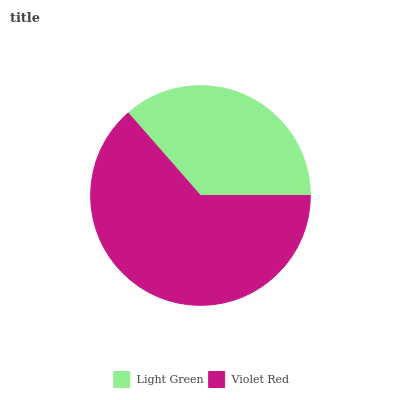Is Light Green the minimum?
Answer yes or no. Yes. Is Violet Red the maximum?
Answer yes or no. Yes. Is Violet Red the minimum?
Answer yes or no. No. Is Violet Red greater than Light Green?
Answer yes or no. Yes. Is Light Green less than Violet Red?
Answer yes or no. Yes. Is Light Green greater than Violet Red?
Answer yes or no. No. Is Violet Red less than Light Green?
Answer yes or no. No. Is Violet Red the high median?
Answer yes or no. Yes. Is Light Green the low median?
Answer yes or no. Yes. Is Light Green the high median?
Answer yes or no. No. Is Violet Red the low median?
Answer yes or no. No. 